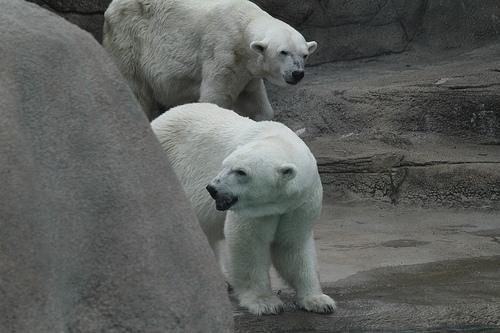What can you infer from the polar bears' activities in the image? It can be inferred that the polar bears are possibly searching for food or roaming their enclosure in the zoo. What is the primary subject of this image? The primary subjects of this image are two polar bears. Evaluate the image's quality based on its subjects' positioning and composition. The image has a well-balanced composition with the subjects centered and various visual elements such as rock walls, water, and stone steps. Mention a possible emotion that the image might evoke. The image can evoke a sense of awe and fascination with the beauty and power of polar bears. Narrate the scene in the image as if you were writing the opening line of a children's story. Once upon a time, in a far away land, there were two beautiful polar bears playing together near a rock wall and a larger rock behind them. State the location where the image was possibly taken. The image was likely taken at a local zoo. Examine and draw a conclusion about the relationship between the two polar bears in the image. The two polar bears seem to have a friendly relationship, as they are walking and exploring side by side, potentially looking for food or seeking entertainment. What are some distinctive properties of the bears in the image? The bears have white fur, big powerful paws, sharp teeth, and keen sense of smell. How many panda claws are present in the image? There are no panda claws in the image; the image shows the paws of polar bears. Analyze the objects or subjects that are interacting in the image. The polar bears are interacting with each other and their environment, which includes rock ledges, water, and stone steps. What is the position of the polar bears in relation to the water? They are on all fours, close to the water. What is the dominant feature in the forefront of the image? The dominant feature in the forefront of the image is the polar bear closest to the viewer. Explain the arrangement of the bears in the image. The bears are walking together slowly, possibly following each other. Examine the zookeeper's red uniform standing close to the enclosure. There is no zookeeper visible in the image. What can be inferred about the bears from the image? They might be at a local zoo and held in captivity. Describe the object present in the background of the image. Rock wall What color are the panda claws? There are no panda claws in the image; the image shows the paws of polar bears, which are white. What structure seems to be near the polar bear? Steps in stone How many ears of the polar bear can be seen in the image? Four ears can be seen; each bear has two ears visible. How many bears are shown in the enclosure? Two polar bears Mention a unique feature of the bears' smell. Polar bears have a highly developed sense of smell, which allows them to detect seals nearly a mile away under the snow. Elaborate on the paws of the bears from the information provided. They have big powerful paws suitable for walking on ice and snow. Can we conclude that the polar bears are fierce and unpredictable? While polar bears can be fierce and unpredictable, this image alone does not provide enough context to make that conclusion. Considering the captured moment, what are the bears likely doing? Walking or possibly searching for food What are the characteristics of the bears' fur? The fur is thick, white, and appears slightly dirty. What does the image suggest about the bears' size and strength? The bears are large and appear strong, as indicated by their robust build. Do the polar bears have a clean appearance? No, the fur of the polar bears appears slightly dirty. What is the relationship between the polar bears? They appear to be companions, possibly from the same social group. Which animal is in the forefront of the image? Polar bear Select the correct statement about the bears in the image. a) They are polar bears 